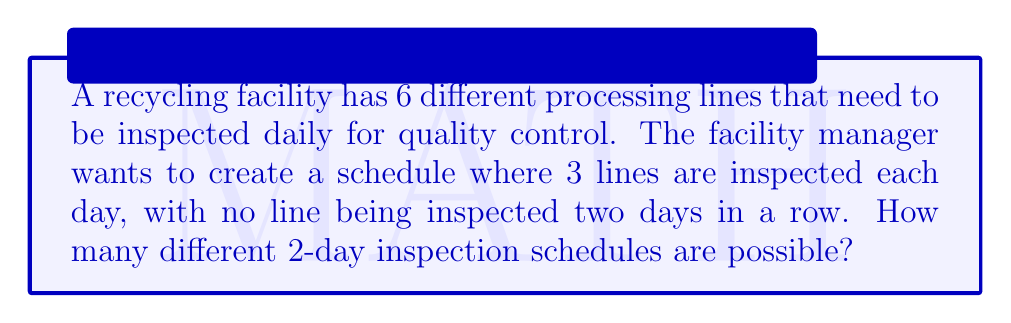Provide a solution to this math problem. Let's approach this step-by-step:

1) For the first day, we need to choose 3 lines out of 6 to inspect. This can be done in $\binom{6}{3}$ ways.

2) For the second day, we cannot inspect any of the 3 lines we inspected on the first day. This means we must inspect the remaining 3 lines.

3) The number of ways to choose 3 lines out of 6 can be calculated using the combination formula:

   $$\binom{6}{3} = \frac{6!}{3!(6-3)!} = \frac{6!}{3!3!} = 20$$

4) For the second day, there is only 1 way to choose the remaining 3 lines.

5) By the multiplication principle, the total number of different 2-day inspection schedules is:

   $$20 \times 1 = 20$$

Therefore, there are 20 different possible 2-day inspection schedules.
Answer: 20 different 2-day inspection schedules 